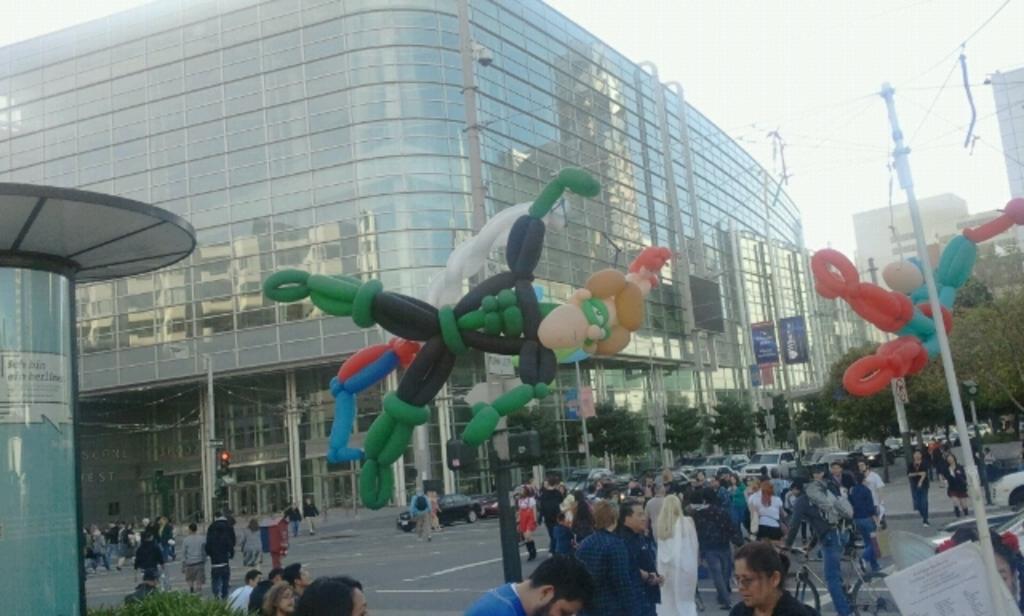How would you summarize this image in a sentence or two? In this image there is a road at the bottom. On the road there are so many people and so many cars. There are balloons in the middle. In the background there is a building which is covered with the glasses. On the right side there is a pole to which there are wires. On the left side there is a glass door. On the right side bottom there are cycles and few cars on the road. 